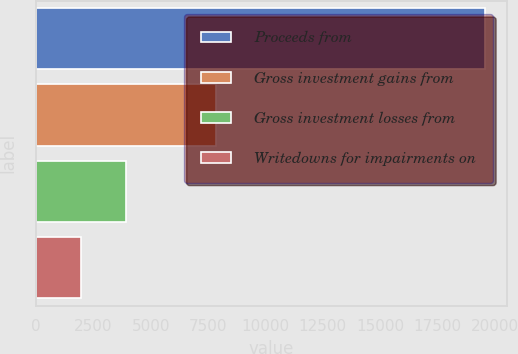<chart> <loc_0><loc_0><loc_500><loc_500><bar_chart><fcel>Proceeds from<fcel>Gross investment gains from<fcel>Gross investment losses from<fcel>Writedowns for impairments on<nl><fcel>19559<fcel>7825.9<fcel>3914.86<fcel>1959.34<nl></chart> 